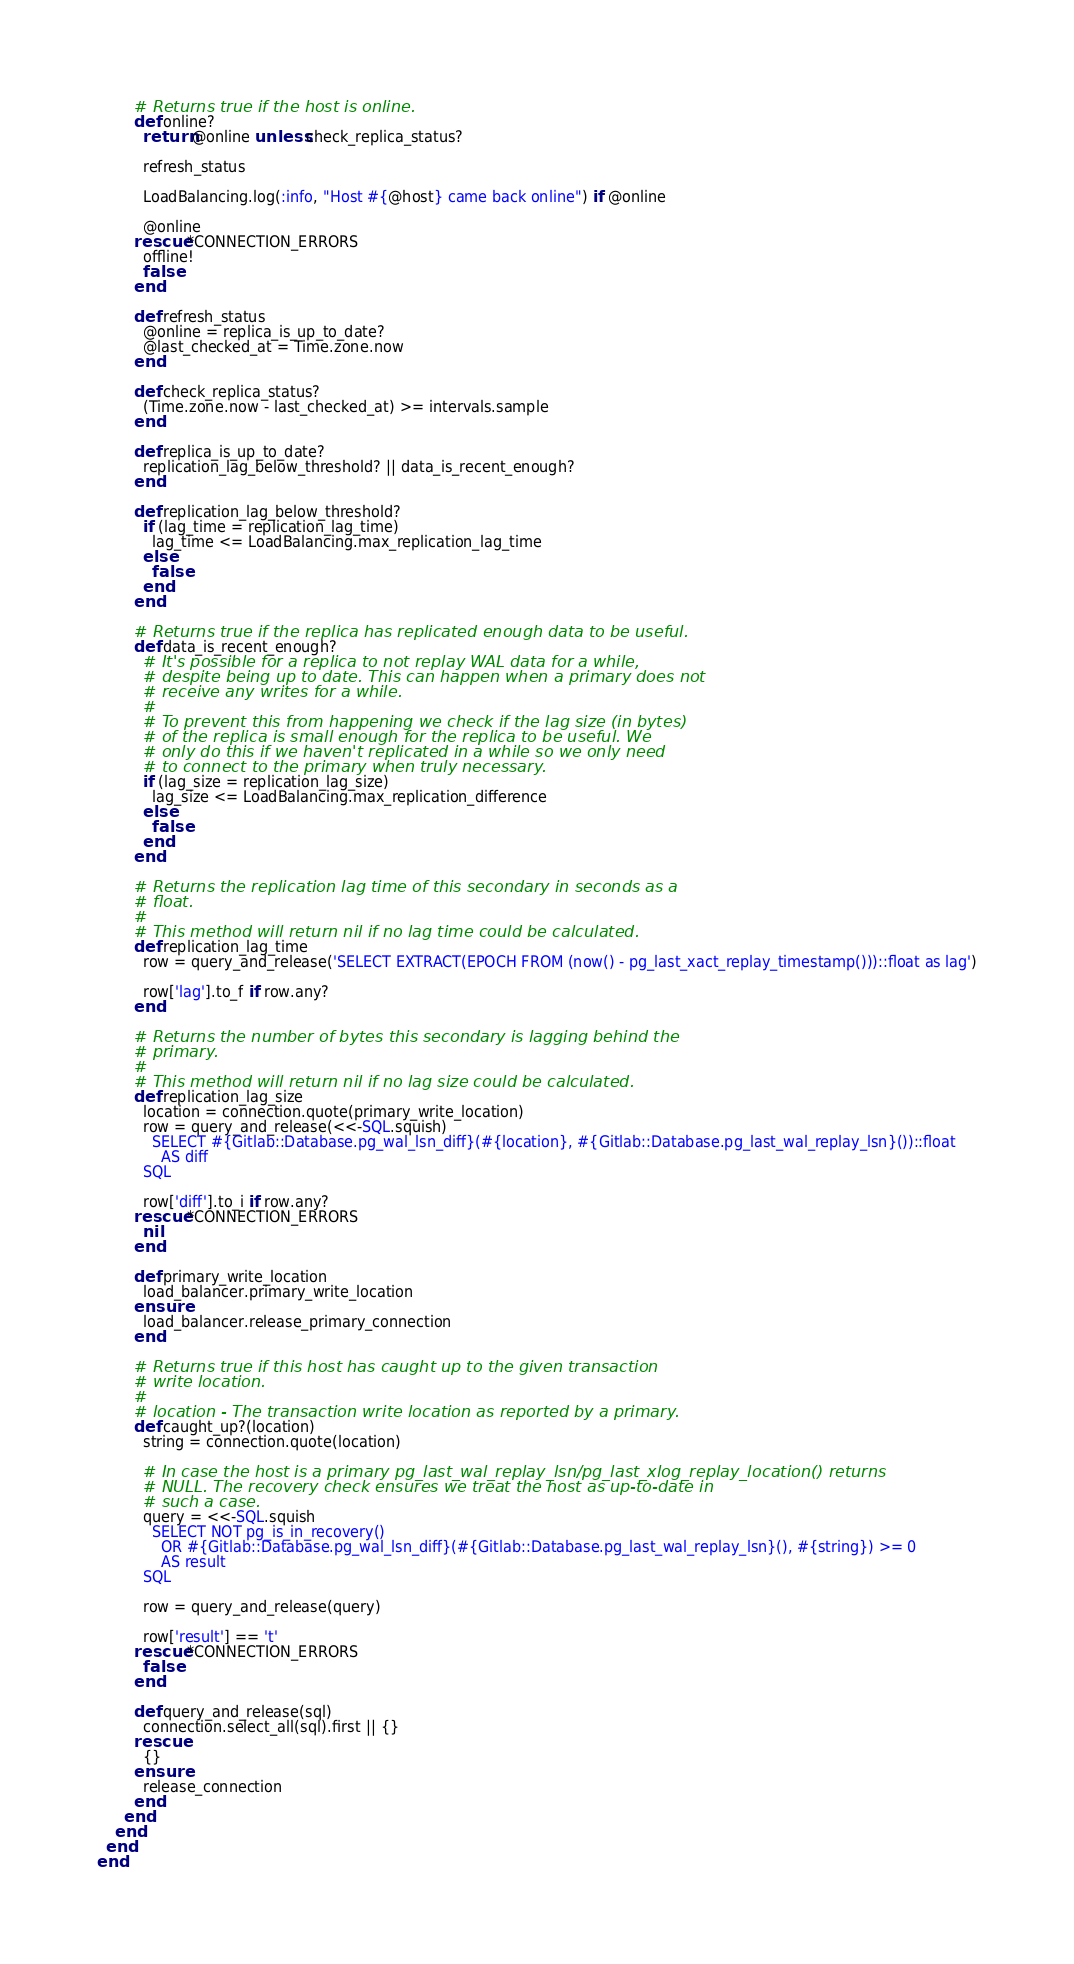<code> <loc_0><loc_0><loc_500><loc_500><_Ruby_>        # Returns true if the host is online.
        def online?
          return @online unless check_replica_status?

          refresh_status

          LoadBalancing.log(:info, "Host #{@host} came back online") if @online

          @online
        rescue *CONNECTION_ERRORS
          offline!
          false
        end

        def refresh_status
          @online = replica_is_up_to_date?
          @last_checked_at = Time.zone.now
        end

        def check_replica_status?
          (Time.zone.now - last_checked_at) >= intervals.sample
        end

        def replica_is_up_to_date?
          replication_lag_below_threshold? || data_is_recent_enough?
        end

        def replication_lag_below_threshold?
          if (lag_time = replication_lag_time)
            lag_time <= LoadBalancing.max_replication_lag_time
          else
            false
          end
        end

        # Returns true if the replica has replicated enough data to be useful.
        def data_is_recent_enough?
          # It's possible for a replica to not replay WAL data for a while,
          # despite being up to date. This can happen when a primary does not
          # receive any writes for a while.
          #
          # To prevent this from happening we check if the lag size (in bytes)
          # of the replica is small enough for the replica to be useful. We
          # only do this if we haven't replicated in a while so we only need
          # to connect to the primary when truly necessary.
          if (lag_size = replication_lag_size)
            lag_size <= LoadBalancing.max_replication_difference
          else
            false
          end
        end

        # Returns the replication lag time of this secondary in seconds as a
        # float.
        #
        # This method will return nil if no lag time could be calculated.
        def replication_lag_time
          row = query_and_release('SELECT EXTRACT(EPOCH FROM (now() - pg_last_xact_replay_timestamp()))::float as lag')

          row['lag'].to_f if row.any?
        end

        # Returns the number of bytes this secondary is lagging behind the
        # primary.
        #
        # This method will return nil if no lag size could be calculated.
        def replication_lag_size
          location = connection.quote(primary_write_location)
          row = query_and_release(<<-SQL.squish)
            SELECT #{Gitlab::Database.pg_wal_lsn_diff}(#{location}, #{Gitlab::Database.pg_last_wal_replay_lsn}())::float
              AS diff
          SQL

          row['diff'].to_i if row.any?
        rescue *CONNECTION_ERRORS
          nil
        end

        def primary_write_location
          load_balancer.primary_write_location
        ensure
          load_balancer.release_primary_connection
        end

        # Returns true if this host has caught up to the given transaction
        # write location.
        #
        # location - The transaction write location as reported by a primary.
        def caught_up?(location)
          string = connection.quote(location)

          # In case the host is a primary pg_last_wal_replay_lsn/pg_last_xlog_replay_location() returns
          # NULL. The recovery check ensures we treat the host as up-to-date in
          # such a case.
          query = <<-SQL.squish
            SELECT NOT pg_is_in_recovery()
              OR #{Gitlab::Database.pg_wal_lsn_diff}(#{Gitlab::Database.pg_last_wal_replay_lsn}(), #{string}) >= 0
              AS result
          SQL

          row = query_and_release(query)

          row['result'] == 't'
        rescue *CONNECTION_ERRORS
          false
        end

        def query_and_release(sql)
          connection.select_all(sql).first || {}
        rescue
          {}
        ensure
          release_connection
        end
      end
    end
  end
end
</code> 